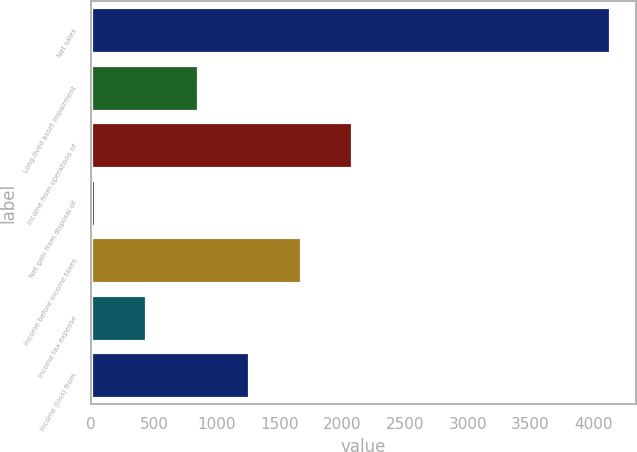<chart> <loc_0><loc_0><loc_500><loc_500><bar_chart><fcel>Net sales<fcel>Long-lived asset impairment<fcel>Income from operations of<fcel>Net gain from disposal of<fcel>Income before income taxes<fcel>Income tax expense<fcel>Income (loss) from<nl><fcel>4131.7<fcel>847.38<fcel>2079<fcel>26.3<fcel>1668.46<fcel>436.84<fcel>1257.92<nl></chart> 